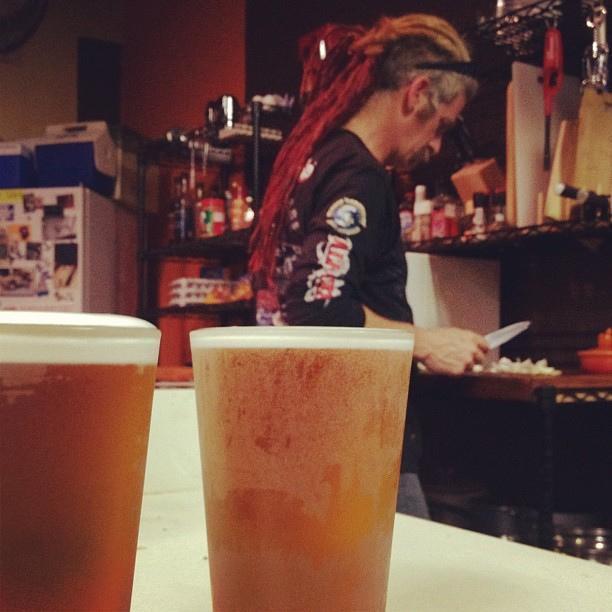How many cups are in the picture?
Give a very brief answer. 2. 